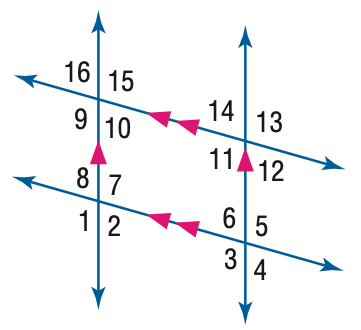Answer the mathemtical geometry problem and directly provide the correct option letter.
Question: In the figure, m \angle 1 = 123. Find the measure of \angle 16.
Choices: A: 47 B: 57 C: 67 D: 123 B 